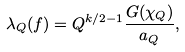<formula> <loc_0><loc_0><loc_500><loc_500>\lambda _ { Q } ( f ) = Q ^ { k / 2 - 1 } \frac { G ( \chi _ { Q } ) } { a _ { Q } } ,</formula> 